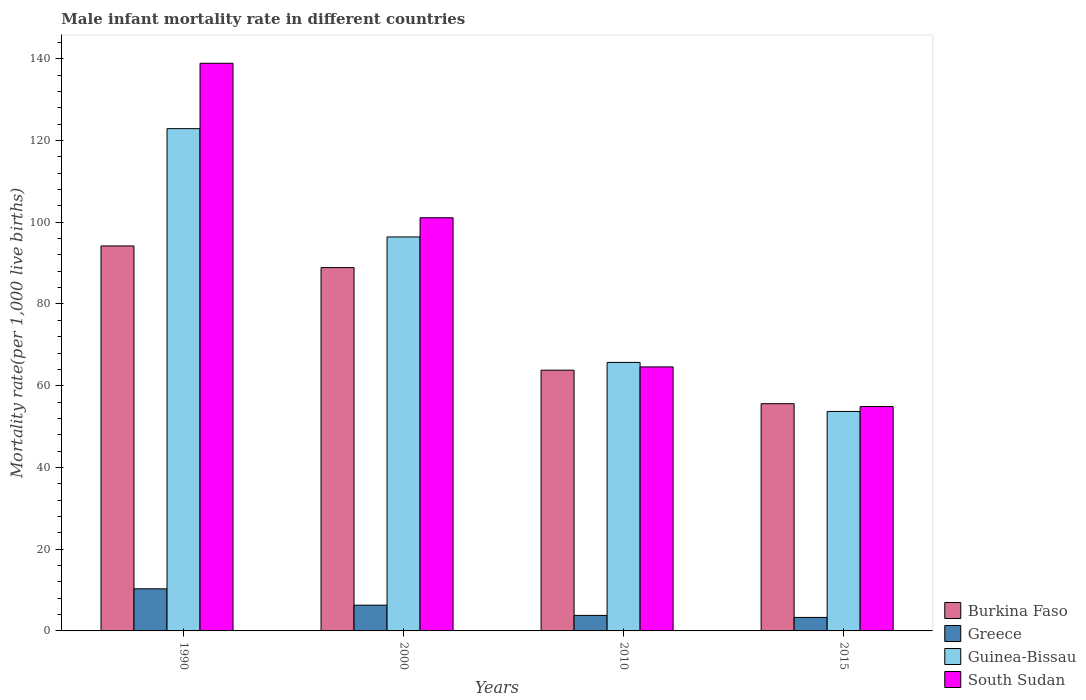How many different coloured bars are there?
Offer a terse response. 4. What is the label of the 4th group of bars from the left?
Make the answer very short. 2015. What is the male infant mortality rate in Guinea-Bissau in 2010?
Keep it short and to the point. 65.7. Across all years, what is the maximum male infant mortality rate in Burkina Faso?
Provide a succinct answer. 94.2. Across all years, what is the minimum male infant mortality rate in Guinea-Bissau?
Your answer should be very brief. 53.7. In which year was the male infant mortality rate in Greece minimum?
Your response must be concise. 2015. What is the total male infant mortality rate in Greece in the graph?
Make the answer very short. 23.7. What is the difference between the male infant mortality rate in Burkina Faso in 2000 and that in 2010?
Provide a short and direct response. 25.1. What is the difference between the male infant mortality rate in Guinea-Bissau in 2015 and the male infant mortality rate in Greece in 1990?
Give a very brief answer. 43.4. What is the average male infant mortality rate in South Sudan per year?
Provide a short and direct response. 89.88. In the year 2015, what is the difference between the male infant mortality rate in Burkina Faso and male infant mortality rate in South Sudan?
Keep it short and to the point. 0.7. In how many years, is the male infant mortality rate in Guinea-Bissau greater than 40?
Keep it short and to the point. 4. What is the ratio of the male infant mortality rate in Greece in 1990 to that in 2010?
Keep it short and to the point. 2.71. Is the male infant mortality rate in South Sudan in 2000 less than that in 2010?
Provide a short and direct response. No. Is the difference between the male infant mortality rate in Burkina Faso in 2000 and 2010 greater than the difference between the male infant mortality rate in South Sudan in 2000 and 2010?
Give a very brief answer. No. What is the difference between the highest and the second highest male infant mortality rate in Burkina Faso?
Your answer should be compact. 5.3. What is the difference between the highest and the lowest male infant mortality rate in Guinea-Bissau?
Ensure brevity in your answer.  69.2. In how many years, is the male infant mortality rate in Greece greater than the average male infant mortality rate in Greece taken over all years?
Your response must be concise. 2. Is it the case that in every year, the sum of the male infant mortality rate in Burkina Faso and male infant mortality rate in Guinea-Bissau is greater than the sum of male infant mortality rate in South Sudan and male infant mortality rate in Greece?
Your answer should be compact. No. What does the 2nd bar from the left in 2010 represents?
Ensure brevity in your answer.  Greece. What does the 1st bar from the right in 1990 represents?
Your response must be concise. South Sudan. Are all the bars in the graph horizontal?
Your response must be concise. No. Are the values on the major ticks of Y-axis written in scientific E-notation?
Your answer should be very brief. No. How are the legend labels stacked?
Make the answer very short. Vertical. What is the title of the graph?
Provide a short and direct response. Male infant mortality rate in different countries. What is the label or title of the X-axis?
Provide a short and direct response. Years. What is the label or title of the Y-axis?
Offer a very short reply. Mortality rate(per 1,0 live births). What is the Mortality rate(per 1,000 live births) of Burkina Faso in 1990?
Provide a short and direct response. 94.2. What is the Mortality rate(per 1,000 live births) in Greece in 1990?
Give a very brief answer. 10.3. What is the Mortality rate(per 1,000 live births) in Guinea-Bissau in 1990?
Ensure brevity in your answer.  122.9. What is the Mortality rate(per 1,000 live births) of South Sudan in 1990?
Offer a terse response. 138.9. What is the Mortality rate(per 1,000 live births) of Burkina Faso in 2000?
Your answer should be very brief. 88.9. What is the Mortality rate(per 1,000 live births) of Guinea-Bissau in 2000?
Ensure brevity in your answer.  96.4. What is the Mortality rate(per 1,000 live births) in South Sudan in 2000?
Your answer should be compact. 101.1. What is the Mortality rate(per 1,000 live births) in Burkina Faso in 2010?
Make the answer very short. 63.8. What is the Mortality rate(per 1,000 live births) of Greece in 2010?
Offer a very short reply. 3.8. What is the Mortality rate(per 1,000 live births) in Guinea-Bissau in 2010?
Ensure brevity in your answer.  65.7. What is the Mortality rate(per 1,000 live births) in South Sudan in 2010?
Offer a terse response. 64.6. What is the Mortality rate(per 1,000 live births) in Burkina Faso in 2015?
Make the answer very short. 55.6. What is the Mortality rate(per 1,000 live births) in Greece in 2015?
Offer a terse response. 3.3. What is the Mortality rate(per 1,000 live births) in Guinea-Bissau in 2015?
Ensure brevity in your answer.  53.7. What is the Mortality rate(per 1,000 live births) of South Sudan in 2015?
Provide a succinct answer. 54.9. Across all years, what is the maximum Mortality rate(per 1,000 live births) in Burkina Faso?
Offer a very short reply. 94.2. Across all years, what is the maximum Mortality rate(per 1,000 live births) in Greece?
Provide a succinct answer. 10.3. Across all years, what is the maximum Mortality rate(per 1,000 live births) of Guinea-Bissau?
Make the answer very short. 122.9. Across all years, what is the maximum Mortality rate(per 1,000 live births) in South Sudan?
Offer a very short reply. 138.9. Across all years, what is the minimum Mortality rate(per 1,000 live births) in Burkina Faso?
Offer a terse response. 55.6. Across all years, what is the minimum Mortality rate(per 1,000 live births) in Greece?
Ensure brevity in your answer.  3.3. Across all years, what is the minimum Mortality rate(per 1,000 live births) of Guinea-Bissau?
Provide a short and direct response. 53.7. Across all years, what is the minimum Mortality rate(per 1,000 live births) of South Sudan?
Offer a terse response. 54.9. What is the total Mortality rate(per 1,000 live births) in Burkina Faso in the graph?
Give a very brief answer. 302.5. What is the total Mortality rate(per 1,000 live births) of Greece in the graph?
Make the answer very short. 23.7. What is the total Mortality rate(per 1,000 live births) of Guinea-Bissau in the graph?
Your answer should be compact. 338.7. What is the total Mortality rate(per 1,000 live births) in South Sudan in the graph?
Provide a short and direct response. 359.5. What is the difference between the Mortality rate(per 1,000 live births) in Burkina Faso in 1990 and that in 2000?
Provide a succinct answer. 5.3. What is the difference between the Mortality rate(per 1,000 live births) in South Sudan in 1990 and that in 2000?
Make the answer very short. 37.8. What is the difference between the Mortality rate(per 1,000 live births) of Burkina Faso in 1990 and that in 2010?
Your answer should be very brief. 30.4. What is the difference between the Mortality rate(per 1,000 live births) in Greece in 1990 and that in 2010?
Keep it short and to the point. 6.5. What is the difference between the Mortality rate(per 1,000 live births) in Guinea-Bissau in 1990 and that in 2010?
Offer a very short reply. 57.2. What is the difference between the Mortality rate(per 1,000 live births) of South Sudan in 1990 and that in 2010?
Provide a succinct answer. 74.3. What is the difference between the Mortality rate(per 1,000 live births) of Burkina Faso in 1990 and that in 2015?
Provide a succinct answer. 38.6. What is the difference between the Mortality rate(per 1,000 live births) in Greece in 1990 and that in 2015?
Keep it short and to the point. 7. What is the difference between the Mortality rate(per 1,000 live births) in Guinea-Bissau in 1990 and that in 2015?
Provide a short and direct response. 69.2. What is the difference between the Mortality rate(per 1,000 live births) in Burkina Faso in 2000 and that in 2010?
Your response must be concise. 25.1. What is the difference between the Mortality rate(per 1,000 live births) of Greece in 2000 and that in 2010?
Your answer should be compact. 2.5. What is the difference between the Mortality rate(per 1,000 live births) in Guinea-Bissau in 2000 and that in 2010?
Keep it short and to the point. 30.7. What is the difference between the Mortality rate(per 1,000 live births) of South Sudan in 2000 and that in 2010?
Provide a short and direct response. 36.5. What is the difference between the Mortality rate(per 1,000 live births) of Burkina Faso in 2000 and that in 2015?
Your answer should be compact. 33.3. What is the difference between the Mortality rate(per 1,000 live births) of Guinea-Bissau in 2000 and that in 2015?
Offer a terse response. 42.7. What is the difference between the Mortality rate(per 1,000 live births) of South Sudan in 2000 and that in 2015?
Give a very brief answer. 46.2. What is the difference between the Mortality rate(per 1,000 live births) in Burkina Faso in 2010 and that in 2015?
Provide a succinct answer. 8.2. What is the difference between the Mortality rate(per 1,000 live births) in Greece in 2010 and that in 2015?
Make the answer very short. 0.5. What is the difference between the Mortality rate(per 1,000 live births) of South Sudan in 2010 and that in 2015?
Keep it short and to the point. 9.7. What is the difference between the Mortality rate(per 1,000 live births) in Burkina Faso in 1990 and the Mortality rate(per 1,000 live births) in Greece in 2000?
Ensure brevity in your answer.  87.9. What is the difference between the Mortality rate(per 1,000 live births) of Burkina Faso in 1990 and the Mortality rate(per 1,000 live births) of South Sudan in 2000?
Provide a short and direct response. -6.9. What is the difference between the Mortality rate(per 1,000 live births) of Greece in 1990 and the Mortality rate(per 1,000 live births) of Guinea-Bissau in 2000?
Your answer should be very brief. -86.1. What is the difference between the Mortality rate(per 1,000 live births) of Greece in 1990 and the Mortality rate(per 1,000 live births) of South Sudan in 2000?
Your answer should be very brief. -90.8. What is the difference between the Mortality rate(per 1,000 live births) in Guinea-Bissau in 1990 and the Mortality rate(per 1,000 live births) in South Sudan in 2000?
Keep it short and to the point. 21.8. What is the difference between the Mortality rate(per 1,000 live births) in Burkina Faso in 1990 and the Mortality rate(per 1,000 live births) in Greece in 2010?
Provide a succinct answer. 90.4. What is the difference between the Mortality rate(per 1,000 live births) in Burkina Faso in 1990 and the Mortality rate(per 1,000 live births) in South Sudan in 2010?
Provide a short and direct response. 29.6. What is the difference between the Mortality rate(per 1,000 live births) in Greece in 1990 and the Mortality rate(per 1,000 live births) in Guinea-Bissau in 2010?
Offer a terse response. -55.4. What is the difference between the Mortality rate(per 1,000 live births) of Greece in 1990 and the Mortality rate(per 1,000 live births) of South Sudan in 2010?
Provide a succinct answer. -54.3. What is the difference between the Mortality rate(per 1,000 live births) in Guinea-Bissau in 1990 and the Mortality rate(per 1,000 live births) in South Sudan in 2010?
Give a very brief answer. 58.3. What is the difference between the Mortality rate(per 1,000 live births) in Burkina Faso in 1990 and the Mortality rate(per 1,000 live births) in Greece in 2015?
Give a very brief answer. 90.9. What is the difference between the Mortality rate(per 1,000 live births) of Burkina Faso in 1990 and the Mortality rate(per 1,000 live births) of Guinea-Bissau in 2015?
Make the answer very short. 40.5. What is the difference between the Mortality rate(per 1,000 live births) of Burkina Faso in 1990 and the Mortality rate(per 1,000 live births) of South Sudan in 2015?
Your response must be concise. 39.3. What is the difference between the Mortality rate(per 1,000 live births) in Greece in 1990 and the Mortality rate(per 1,000 live births) in Guinea-Bissau in 2015?
Provide a succinct answer. -43.4. What is the difference between the Mortality rate(per 1,000 live births) in Greece in 1990 and the Mortality rate(per 1,000 live births) in South Sudan in 2015?
Your answer should be very brief. -44.6. What is the difference between the Mortality rate(per 1,000 live births) of Guinea-Bissau in 1990 and the Mortality rate(per 1,000 live births) of South Sudan in 2015?
Offer a terse response. 68. What is the difference between the Mortality rate(per 1,000 live births) in Burkina Faso in 2000 and the Mortality rate(per 1,000 live births) in Greece in 2010?
Ensure brevity in your answer.  85.1. What is the difference between the Mortality rate(per 1,000 live births) in Burkina Faso in 2000 and the Mortality rate(per 1,000 live births) in Guinea-Bissau in 2010?
Make the answer very short. 23.2. What is the difference between the Mortality rate(per 1,000 live births) of Burkina Faso in 2000 and the Mortality rate(per 1,000 live births) of South Sudan in 2010?
Ensure brevity in your answer.  24.3. What is the difference between the Mortality rate(per 1,000 live births) in Greece in 2000 and the Mortality rate(per 1,000 live births) in Guinea-Bissau in 2010?
Offer a very short reply. -59.4. What is the difference between the Mortality rate(per 1,000 live births) in Greece in 2000 and the Mortality rate(per 1,000 live births) in South Sudan in 2010?
Offer a terse response. -58.3. What is the difference between the Mortality rate(per 1,000 live births) of Guinea-Bissau in 2000 and the Mortality rate(per 1,000 live births) of South Sudan in 2010?
Your answer should be very brief. 31.8. What is the difference between the Mortality rate(per 1,000 live births) in Burkina Faso in 2000 and the Mortality rate(per 1,000 live births) in Greece in 2015?
Ensure brevity in your answer.  85.6. What is the difference between the Mortality rate(per 1,000 live births) of Burkina Faso in 2000 and the Mortality rate(per 1,000 live births) of Guinea-Bissau in 2015?
Give a very brief answer. 35.2. What is the difference between the Mortality rate(per 1,000 live births) in Burkina Faso in 2000 and the Mortality rate(per 1,000 live births) in South Sudan in 2015?
Make the answer very short. 34. What is the difference between the Mortality rate(per 1,000 live births) of Greece in 2000 and the Mortality rate(per 1,000 live births) of Guinea-Bissau in 2015?
Your answer should be very brief. -47.4. What is the difference between the Mortality rate(per 1,000 live births) of Greece in 2000 and the Mortality rate(per 1,000 live births) of South Sudan in 2015?
Your response must be concise. -48.6. What is the difference between the Mortality rate(per 1,000 live births) of Guinea-Bissau in 2000 and the Mortality rate(per 1,000 live births) of South Sudan in 2015?
Offer a terse response. 41.5. What is the difference between the Mortality rate(per 1,000 live births) of Burkina Faso in 2010 and the Mortality rate(per 1,000 live births) of Greece in 2015?
Ensure brevity in your answer.  60.5. What is the difference between the Mortality rate(per 1,000 live births) in Burkina Faso in 2010 and the Mortality rate(per 1,000 live births) in South Sudan in 2015?
Make the answer very short. 8.9. What is the difference between the Mortality rate(per 1,000 live births) in Greece in 2010 and the Mortality rate(per 1,000 live births) in Guinea-Bissau in 2015?
Offer a very short reply. -49.9. What is the difference between the Mortality rate(per 1,000 live births) in Greece in 2010 and the Mortality rate(per 1,000 live births) in South Sudan in 2015?
Keep it short and to the point. -51.1. What is the difference between the Mortality rate(per 1,000 live births) of Guinea-Bissau in 2010 and the Mortality rate(per 1,000 live births) of South Sudan in 2015?
Offer a terse response. 10.8. What is the average Mortality rate(per 1,000 live births) in Burkina Faso per year?
Provide a short and direct response. 75.62. What is the average Mortality rate(per 1,000 live births) of Greece per year?
Make the answer very short. 5.92. What is the average Mortality rate(per 1,000 live births) in Guinea-Bissau per year?
Make the answer very short. 84.67. What is the average Mortality rate(per 1,000 live births) in South Sudan per year?
Your answer should be compact. 89.88. In the year 1990, what is the difference between the Mortality rate(per 1,000 live births) in Burkina Faso and Mortality rate(per 1,000 live births) in Greece?
Your response must be concise. 83.9. In the year 1990, what is the difference between the Mortality rate(per 1,000 live births) of Burkina Faso and Mortality rate(per 1,000 live births) of Guinea-Bissau?
Make the answer very short. -28.7. In the year 1990, what is the difference between the Mortality rate(per 1,000 live births) of Burkina Faso and Mortality rate(per 1,000 live births) of South Sudan?
Ensure brevity in your answer.  -44.7. In the year 1990, what is the difference between the Mortality rate(per 1,000 live births) in Greece and Mortality rate(per 1,000 live births) in Guinea-Bissau?
Ensure brevity in your answer.  -112.6. In the year 1990, what is the difference between the Mortality rate(per 1,000 live births) of Greece and Mortality rate(per 1,000 live births) of South Sudan?
Provide a succinct answer. -128.6. In the year 2000, what is the difference between the Mortality rate(per 1,000 live births) in Burkina Faso and Mortality rate(per 1,000 live births) in Greece?
Give a very brief answer. 82.6. In the year 2000, what is the difference between the Mortality rate(per 1,000 live births) in Greece and Mortality rate(per 1,000 live births) in Guinea-Bissau?
Your response must be concise. -90.1. In the year 2000, what is the difference between the Mortality rate(per 1,000 live births) in Greece and Mortality rate(per 1,000 live births) in South Sudan?
Your answer should be very brief. -94.8. In the year 2010, what is the difference between the Mortality rate(per 1,000 live births) of Greece and Mortality rate(per 1,000 live births) of Guinea-Bissau?
Ensure brevity in your answer.  -61.9. In the year 2010, what is the difference between the Mortality rate(per 1,000 live births) of Greece and Mortality rate(per 1,000 live births) of South Sudan?
Give a very brief answer. -60.8. In the year 2010, what is the difference between the Mortality rate(per 1,000 live births) in Guinea-Bissau and Mortality rate(per 1,000 live births) in South Sudan?
Make the answer very short. 1.1. In the year 2015, what is the difference between the Mortality rate(per 1,000 live births) in Burkina Faso and Mortality rate(per 1,000 live births) in Greece?
Give a very brief answer. 52.3. In the year 2015, what is the difference between the Mortality rate(per 1,000 live births) in Burkina Faso and Mortality rate(per 1,000 live births) in South Sudan?
Your answer should be very brief. 0.7. In the year 2015, what is the difference between the Mortality rate(per 1,000 live births) of Greece and Mortality rate(per 1,000 live births) of Guinea-Bissau?
Give a very brief answer. -50.4. In the year 2015, what is the difference between the Mortality rate(per 1,000 live births) in Greece and Mortality rate(per 1,000 live births) in South Sudan?
Keep it short and to the point. -51.6. In the year 2015, what is the difference between the Mortality rate(per 1,000 live births) of Guinea-Bissau and Mortality rate(per 1,000 live births) of South Sudan?
Give a very brief answer. -1.2. What is the ratio of the Mortality rate(per 1,000 live births) in Burkina Faso in 1990 to that in 2000?
Your answer should be compact. 1.06. What is the ratio of the Mortality rate(per 1,000 live births) of Greece in 1990 to that in 2000?
Your answer should be compact. 1.63. What is the ratio of the Mortality rate(per 1,000 live births) of Guinea-Bissau in 1990 to that in 2000?
Offer a terse response. 1.27. What is the ratio of the Mortality rate(per 1,000 live births) of South Sudan in 1990 to that in 2000?
Provide a succinct answer. 1.37. What is the ratio of the Mortality rate(per 1,000 live births) in Burkina Faso in 1990 to that in 2010?
Give a very brief answer. 1.48. What is the ratio of the Mortality rate(per 1,000 live births) in Greece in 1990 to that in 2010?
Give a very brief answer. 2.71. What is the ratio of the Mortality rate(per 1,000 live births) of Guinea-Bissau in 1990 to that in 2010?
Provide a short and direct response. 1.87. What is the ratio of the Mortality rate(per 1,000 live births) of South Sudan in 1990 to that in 2010?
Provide a short and direct response. 2.15. What is the ratio of the Mortality rate(per 1,000 live births) of Burkina Faso in 1990 to that in 2015?
Make the answer very short. 1.69. What is the ratio of the Mortality rate(per 1,000 live births) in Greece in 1990 to that in 2015?
Provide a short and direct response. 3.12. What is the ratio of the Mortality rate(per 1,000 live births) of Guinea-Bissau in 1990 to that in 2015?
Offer a terse response. 2.29. What is the ratio of the Mortality rate(per 1,000 live births) of South Sudan in 1990 to that in 2015?
Keep it short and to the point. 2.53. What is the ratio of the Mortality rate(per 1,000 live births) in Burkina Faso in 2000 to that in 2010?
Give a very brief answer. 1.39. What is the ratio of the Mortality rate(per 1,000 live births) of Greece in 2000 to that in 2010?
Your answer should be very brief. 1.66. What is the ratio of the Mortality rate(per 1,000 live births) of Guinea-Bissau in 2000 to that in 2010?
Provide a succinct answer. 1.47. What is the ratio of the Mortality rate(per 1,000 live births) of South Sudan in 2000 to that in 2010?
Your answer should be compact. 1.56. What is the ratio of the Mortality rate(per 1,000 live births) in Burkina Faso in 2000 to that in 2015?
Your response must be concise. 1.6. What is the ratio of the Mortality rate(per 1,000 live births) of Greece in 2000 to that in 2015?
Ensure brevity in your answer.  1.91. What is the ratio of the Mortality rate(per 1,000 live births) of Guinea-Bissau in 2000 to that in 2015?
Offer a terse response. 1.8. What is the ratio of the Mortality rate(per 1,000 live births) in South Sudan in 2000 to that in 2015?
Ensure brevity in your answer.  1.84. What is the ratio of the Mortality rate(per 1,000 live births) of Burkina Faso in 2010 to that in 2015?
Your answer should be compact. 1.15. What is the ratio of the Mortality rate(per 1,000 live births) of Greece in 2010 to that in 2015?
Make the answer very short. 1.15. What is the ratio of the Mortality rate(per 1,000 live births) in Guinea-Bissau in 2010 to that in 2015?
Make the answer very short. 1.22. What is the ratio of the Mortality rate(per 1,000 live births) in South Sudan in 2010 to that in 2015?
Your answer should be very brief. 1.18. What is the difference between the highest and the second highest Mortality rate(per 1,000 live births) of Burkina Faso?
Your answer should be very brief. 5.3. What is the difference between the highest and the second highest Mortality rate(per 1,000 live births) in Greece?
Keep it short and to the point. 4. What is the difference between the highest and the second highest Mortality rate(per 1,000 live births) of South Sudan?
Your response must be concise. 37.8. What is the difference between the highest and the lowest Mortality rate(per 1,000 live births) of Burkina Faso?
Keep it short and to the point. 38.6. What is the difference between the highest and the lowest Mortality rate(per 1,000 live births) of Greece?
Provide a short and direct response. 7. What is the difference between the highest and the lowest Mortality rate(per 1,000 live births) of Guinea-Bissau?
Your answer should be compact. 69.2. 